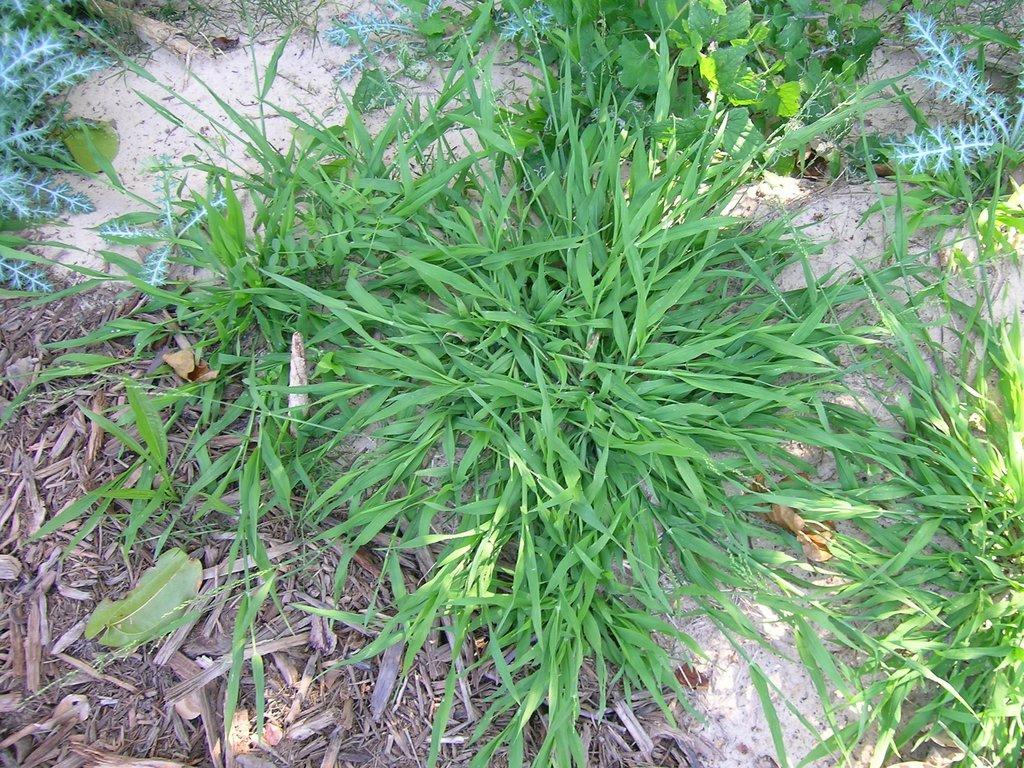What type of vegetation is visible in the image? There is grass in the image. What other type of vegetation can be seen in the image? There are plants in the image. What type of yam is being used as a decoration in the image? There is no yam present in the image; it only features grass and plants. 